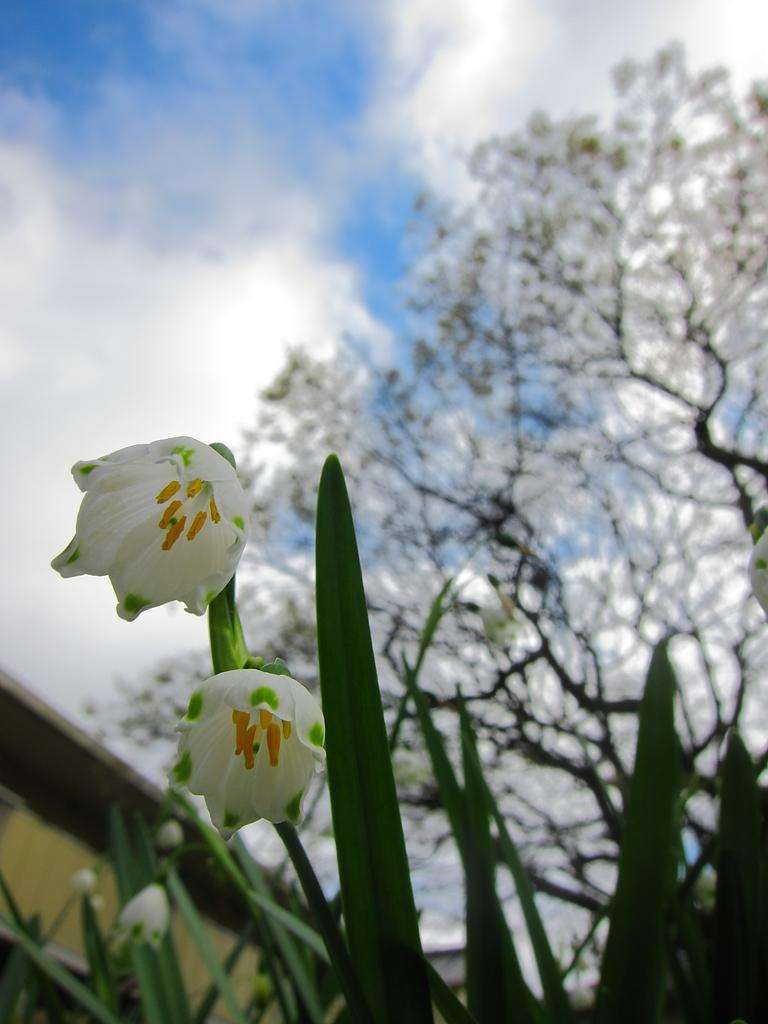What type of plant life is visible in the image? There are flowers and leaves in the image. What can be seen in the background of the image? There are trees and the sky visible in the background of the image. What is the condition of the sky in the image? Clouds are present in the sky in the image. What advice is the flower giving to the leaves in the image? There is no indication in the image that the flower is giving advice to the leaves, as plants do not communicate in this manner. 